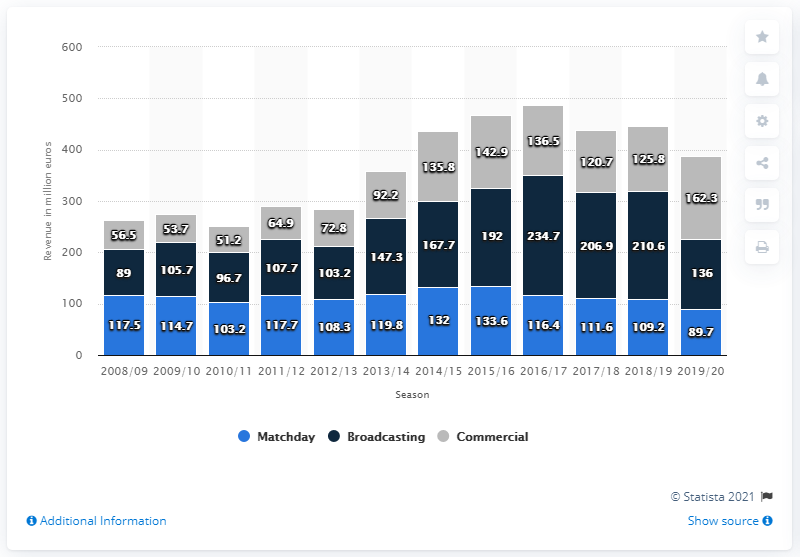Highlight a few significant elements in this photo. According to the information available, Arsenal earned 136 million from the broadcasting stream in the 2019/2020 season. 